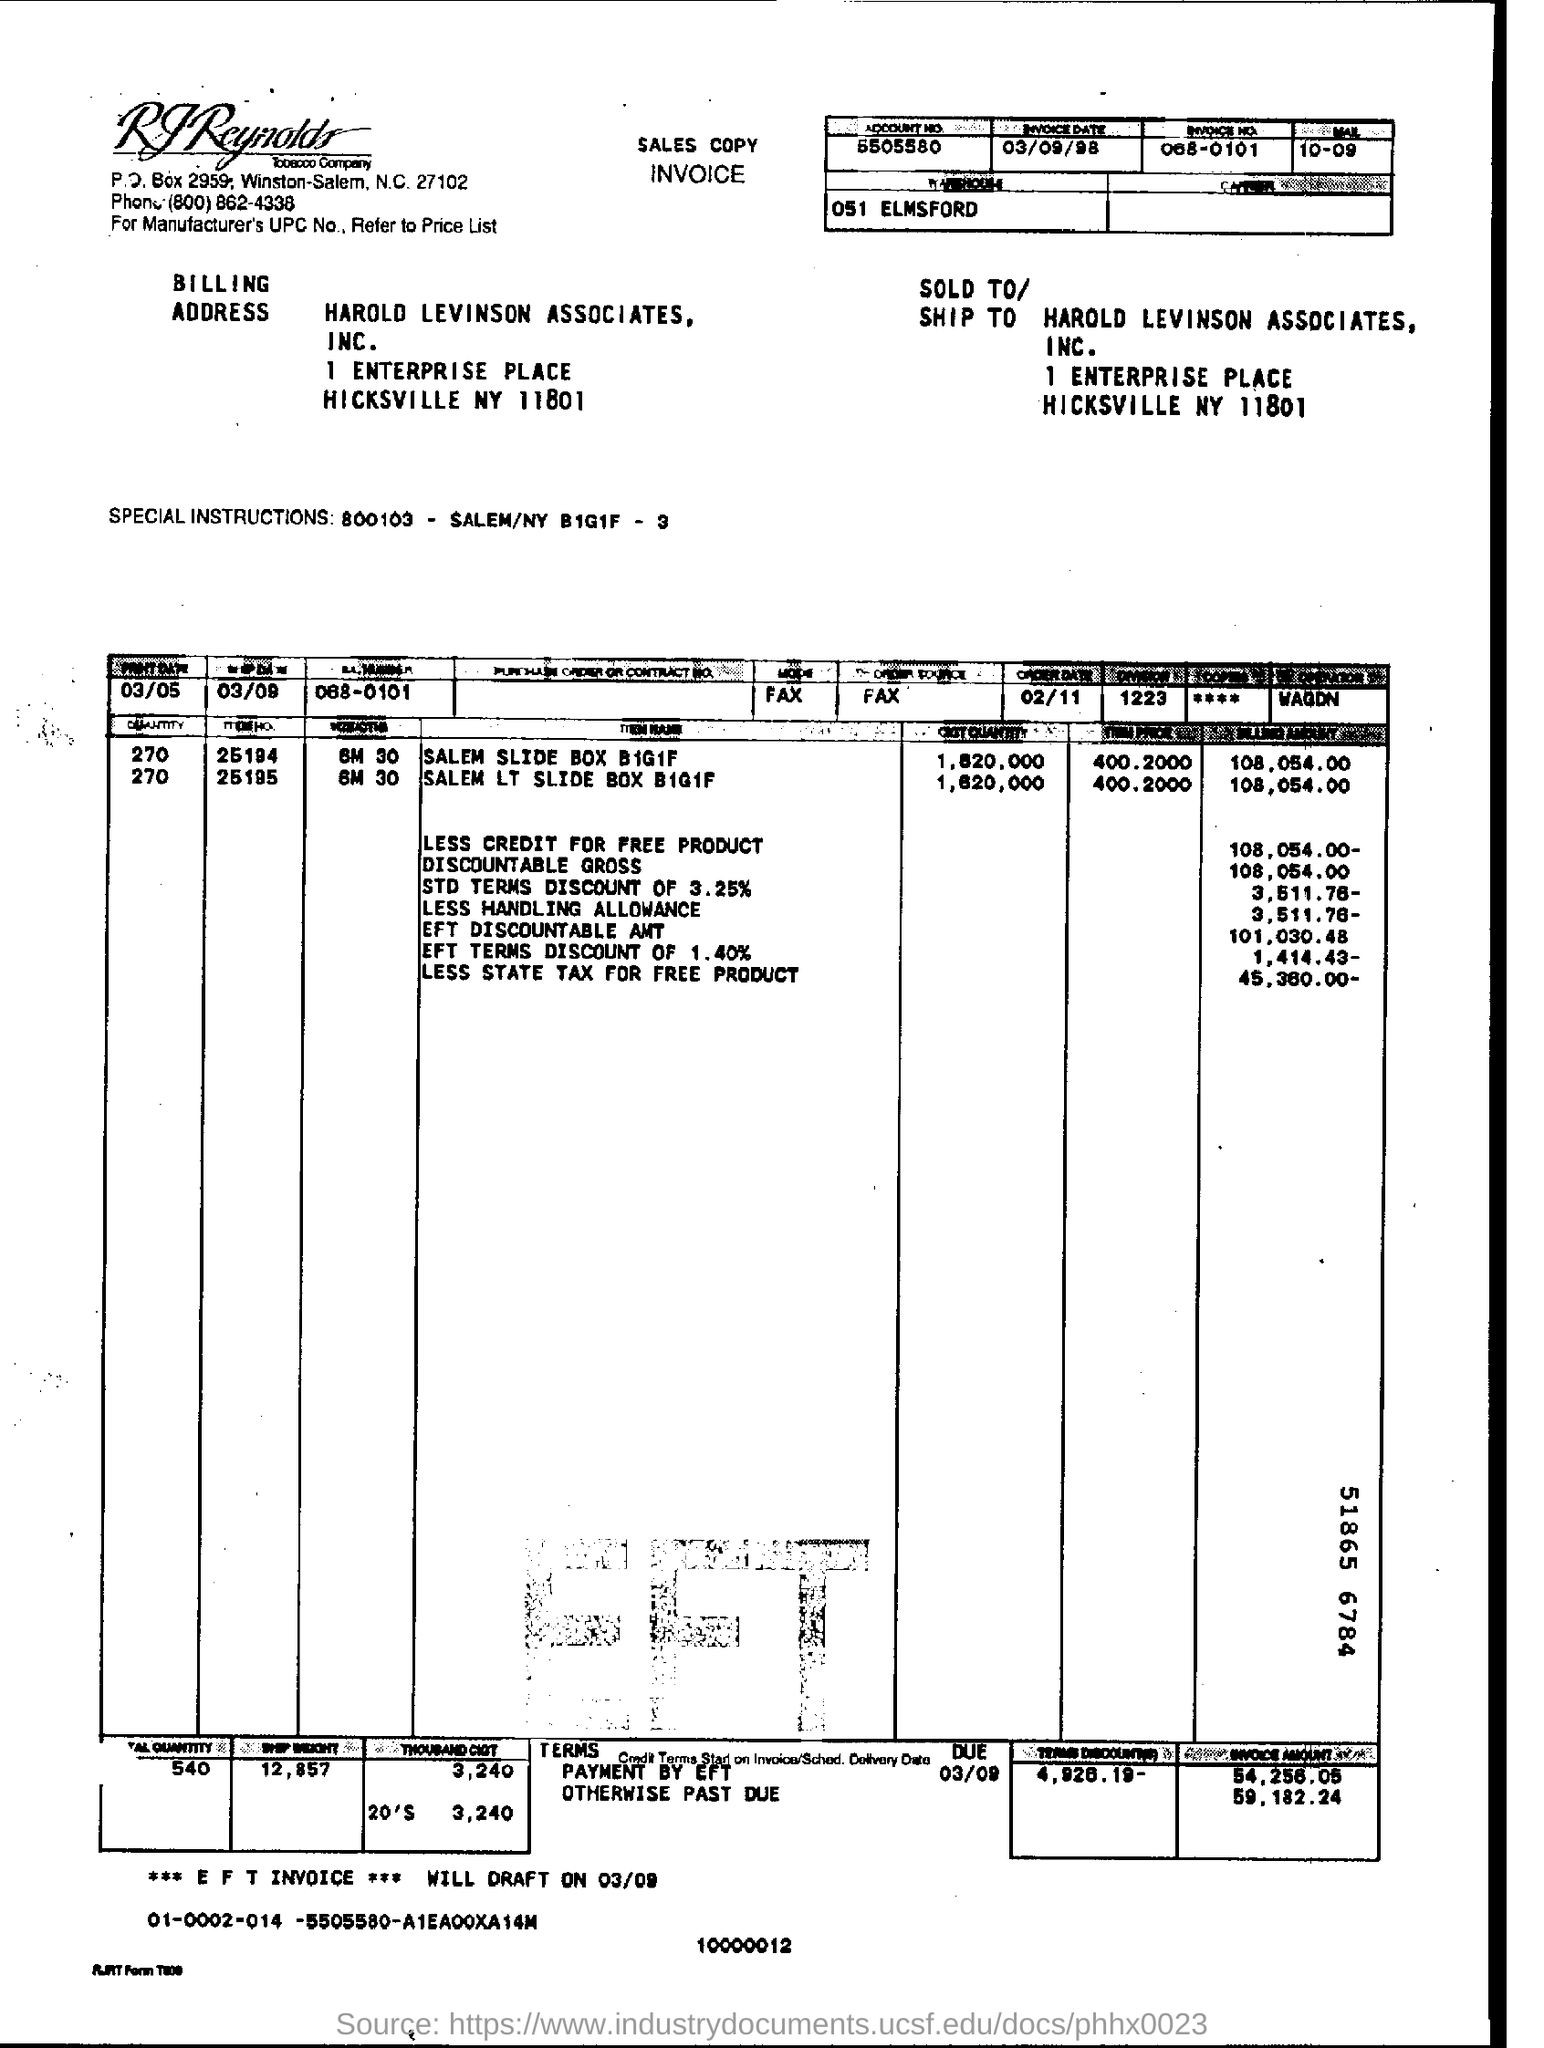What is the invoice date ?
Keep it short and to the point. 03/09/98. 